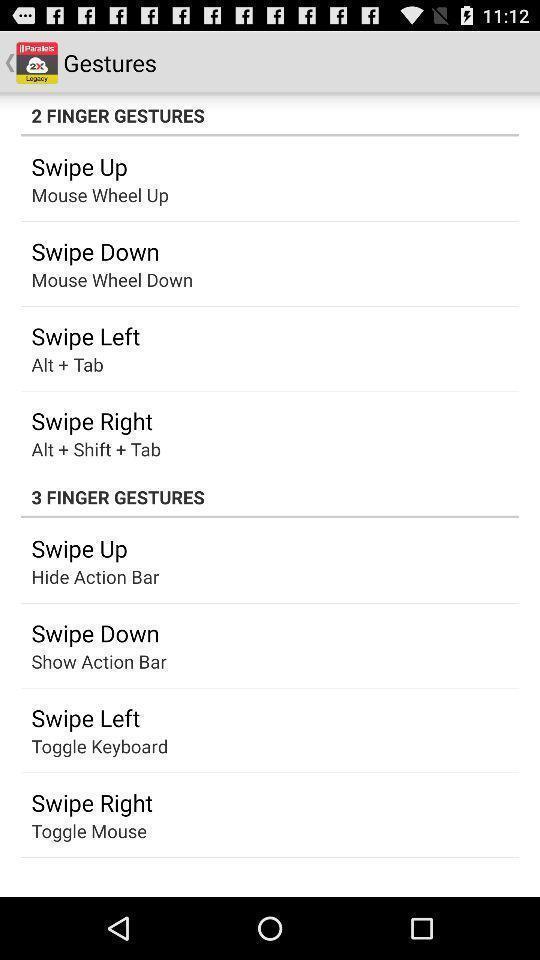Provide a textual representation of this image. Page with gestures in options. 